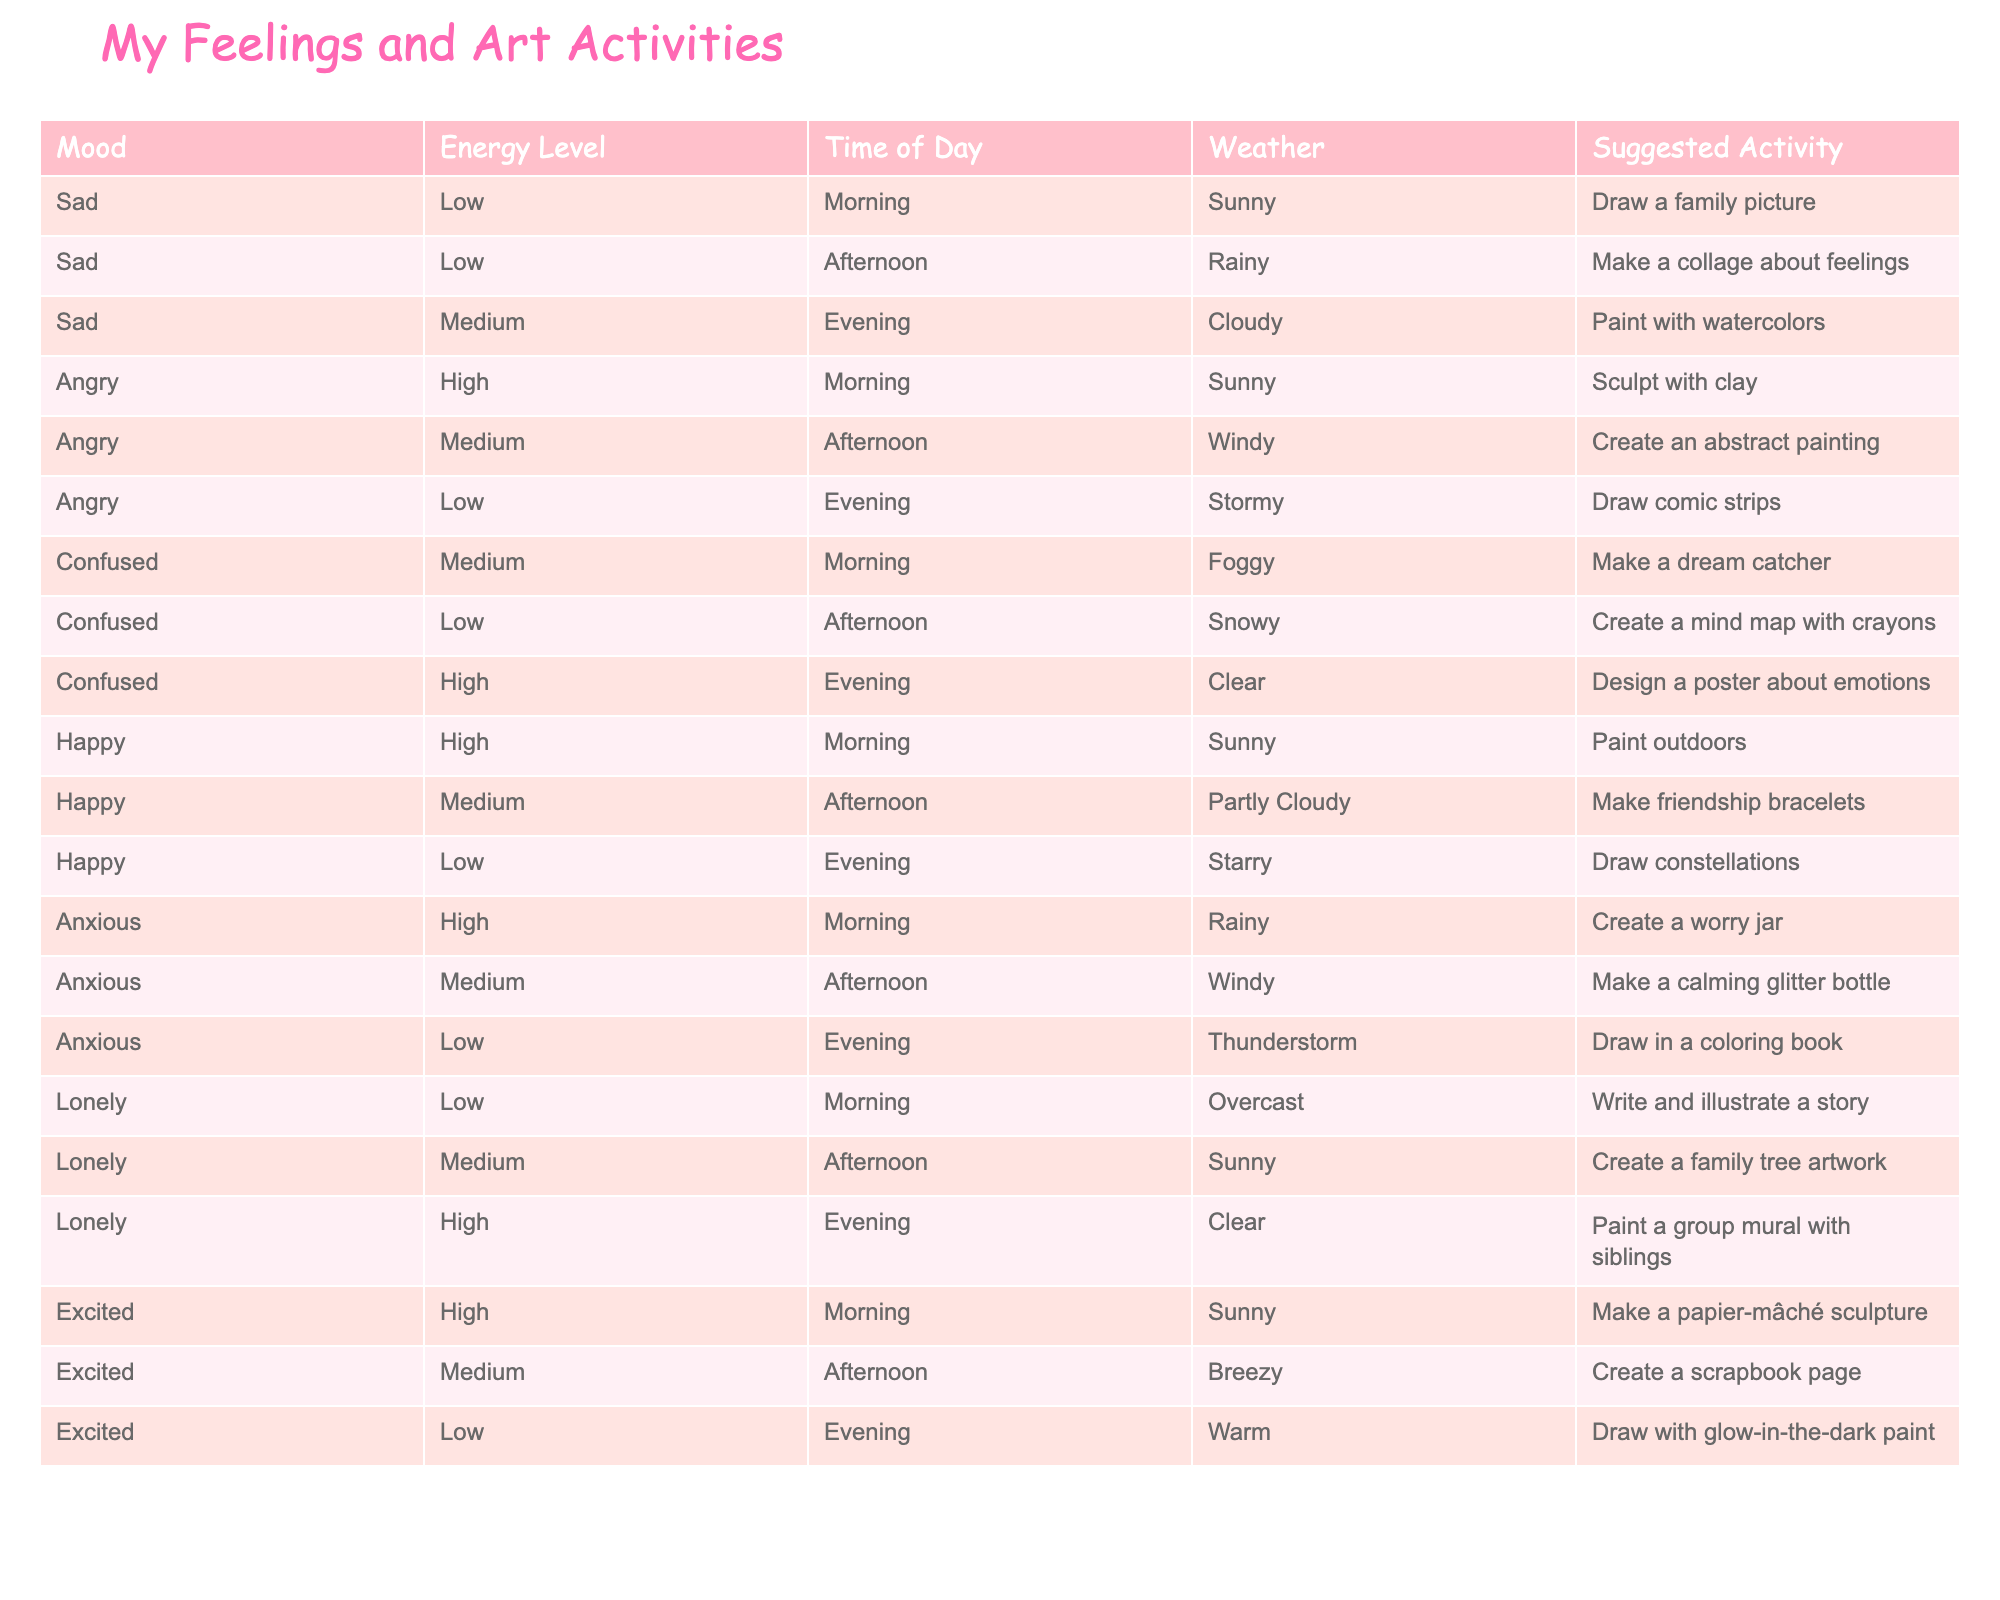What suggested activity is associated with a "confused" mood in the morning? In the morning, when the mood is "confused" with a medium energy level and foggy weather, the suggested activity is to "Make a dream catcher."
Answer: Make a dream catcher How many activities suggest using "clay"? There are two activities that suggest using "clay": "Sculpt with clay" for an angry mood in the morning and "Create a family tree artwork" as a medium energy activity for someone feeling lonely. Therefore, the total is 2.
Answer: 2 Is it true that painting with watercolors is suggested in the evening? Yes, there is a suggestion for painting with watercolors in the evening when feeling sad with medium energy and cloudy weather.
Answer: Yes What energy levels are associated with "happy" activities? The "happy" activities span across all three energy levels: high, medium, and low. Specifically, "Paint outdoors" is for high, "Make friendship bracelets" for medium, and "Draw constellations" for low.
Answer: High, medium, low If someone feels anxious and it's a rainy morning, what activity should they do? When feeling anxious, high energy in the morning during rainy weather suggests creating a worry jar. This provides a method for managing anxiety.
Answer: Create a worry jar 